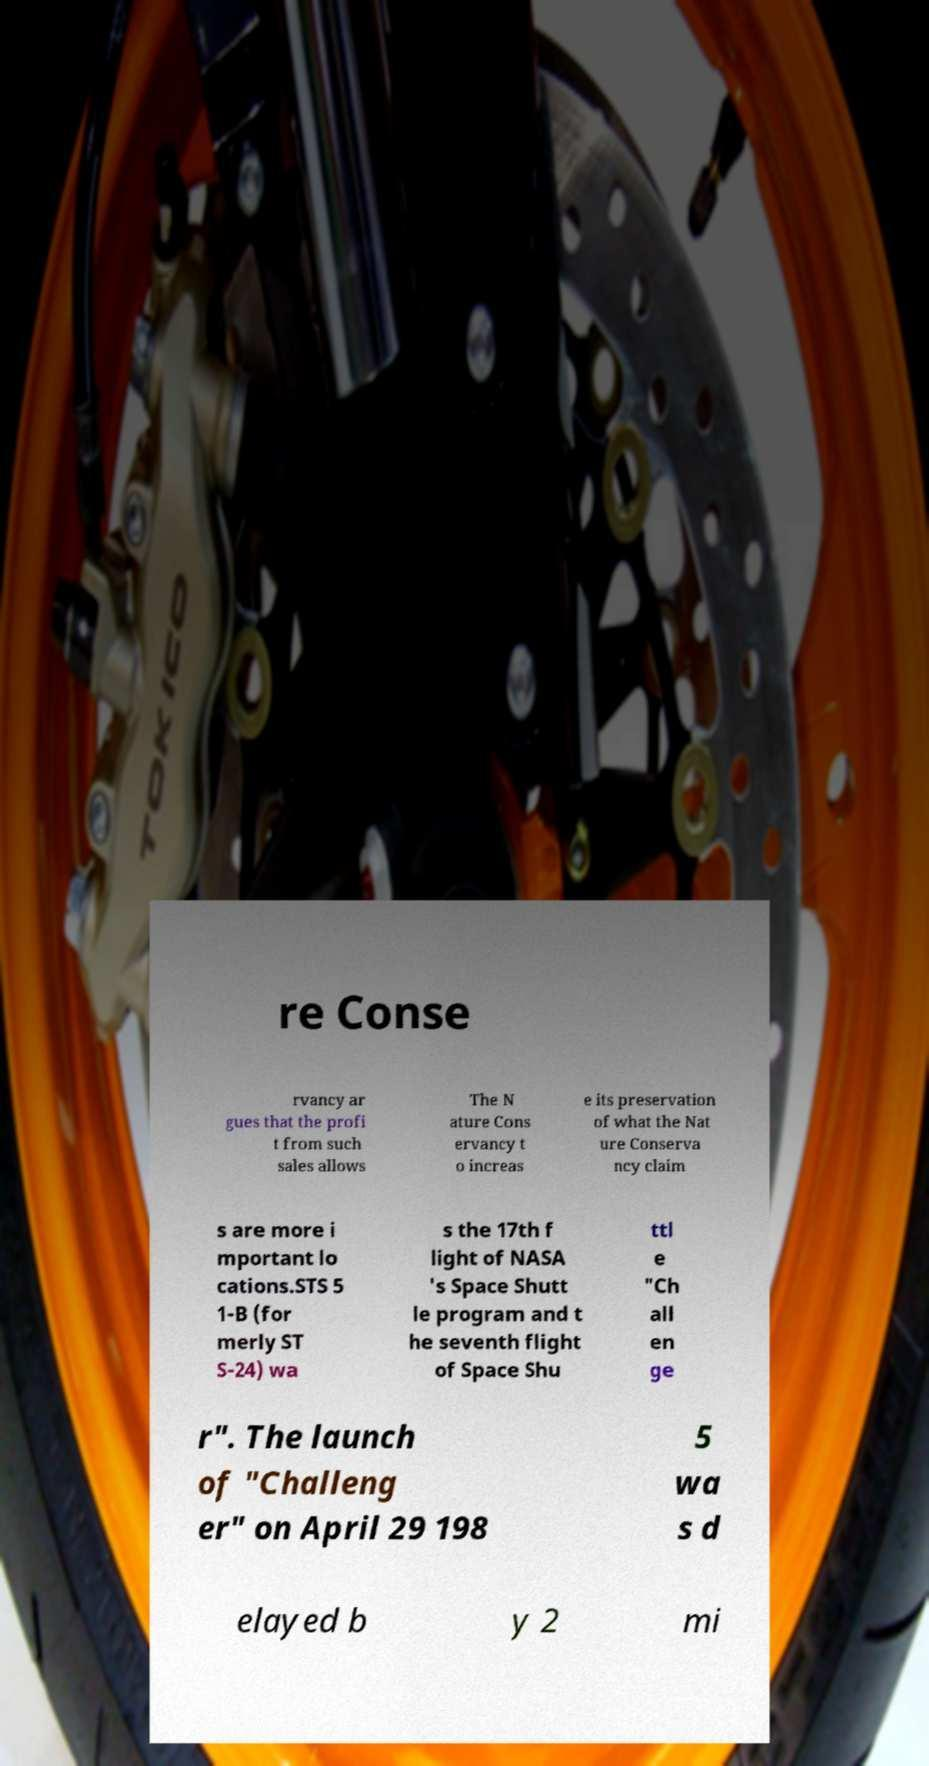Can you read and provide the text displayed in the image?This photo seems to have some interesting text. Can you extract and type it out for me? re Conse rvancy ar gues that the profi t from such sales allows The N ature Cons ervancy t o increas e its preservation of what the Nat ure Conserva ncy claim s are more i mportant lo cations.STS 5 1-B (for merly ST S-24) wa s the 17th f light of NASA 's Space Shutt le program and t he seventh flight of Space Shu ttl e "Ch all en ge r". The launch of "Challeng er" on April 29 198 5 wa s d elayed b y 2 mi 